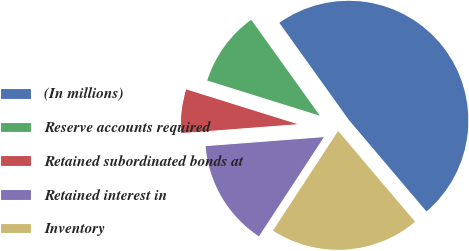Convert chart. <chart><loc_0><loc_0><loc_500><loc_500><pie_chart><fcel>(In millions)<fcel>Reserve accounts required<fcel>Retained subordinated bonds at<fcel>Retained interest in<fcel>Inventory<nl><fcel>48.69%<fcel>10.29%<fcel>6.03%<fcel>14.56%<fcel>20.42%<nl></chart> 